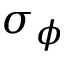<formula> <loc_0><loc_0><loc_500><loc_500>\sigma _ { \phi }</formula> 